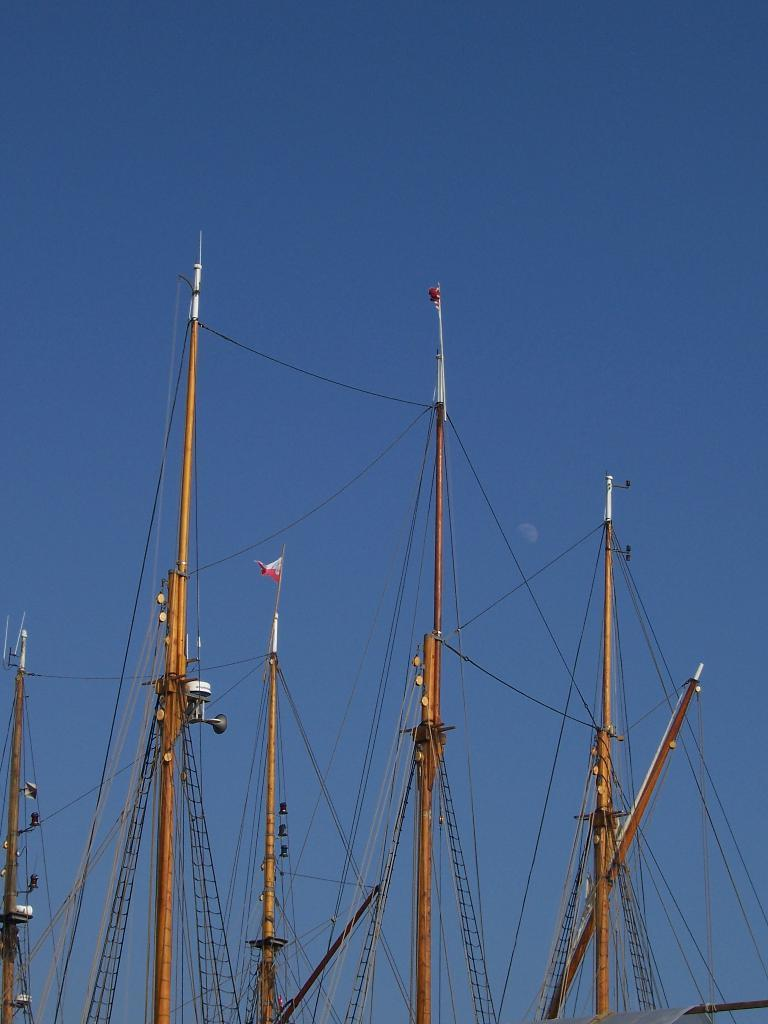What is the primary subject of the image? The image contains a ship, which is the main focus of the image. Can you describe the ship in the image? Unfortunately, the facts provided do not give any specific details about the ship. What color is the sky in the image? The sky is blue in color. What type of baseball game is being played on the ship in the image? There is no baseball game or any reference to baseball in the image; it features a ship and a blue sky. 